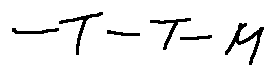Convert formula to latex. <formula><loc_0><loc_0><loc_500><loc_500>- T - T - M</formula> 